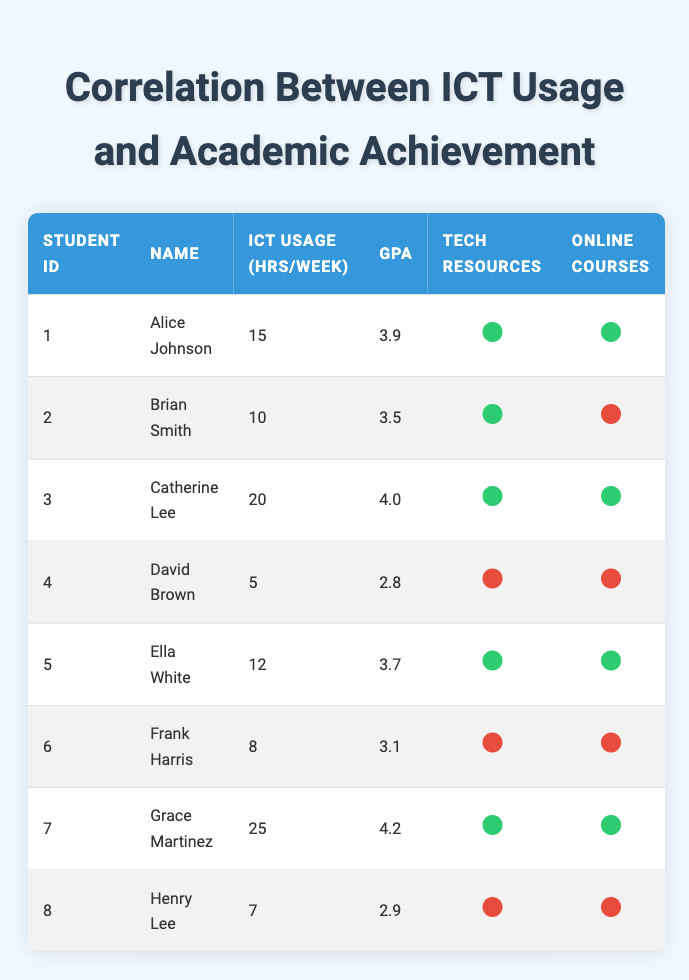What is the GPA of the student who uses ICT for 25 hours per week? Referring to the table, Grace Martinez is the student who uses ICT for 25 hours per week, and her GPA is 4.2.
Answer: 4.2 How many students have access to tech resources? By checking the table, students Alice Johnson, Brian Smith, Catherine Lee, Ella White, Grace Martinez have access to tech resources. This totals to 5 students.
Answer: 5 What is the average GPA of students who participate in online courses? The students who participate in online courses are Alice Johnson, Catherine Lee, Ella White, and Grace Martinez. Their GPAs are 3.9, 4.0, 3.7, and 4.2. The total GPA sum is 15.8, and divided by 4 gives an average of 3.95.
Answer: 3.95 Is there any student who uses ICT for more than 20 hours and has a GPA below 3.5? Referring to the table, Grace Martinez uses ICT for 25 hours and has a GPA of 4.2, and Catherine Lee uses ICT for 20 hours and has a GPA of 4.0. Thus, there is no student fitting this criteria.
Answer: No What is the difference between the highest and lowest GPA among students with access to tech resources? The highest GPA among students with access to tech resources is 4.2 (Grace Martinez) and the lowest is 3.5 (Brian Smith). The difference is 4.2 - 3.5 = 0.7.
Answer: 0.7 How many total ICT usage hours per week is reported by students who don't have access to tech resources? The students without access to tech resources are David Brown, Frank Harris, and Henry Lee. Their ICT usage hours are 5, 8 and 7 respectively. Total ICT usage is 5 + 8 + 7 = 20 hours.
Answer: 20 Which student has the lowest GPA and does not participate in online courses? By checking the table, David Brown has the lowest GPA at 2.8 and does not participate in online courses.
Answer: David Brown How many students have both access to tech resources and participate in online courses? From the table, the students who meet both criteria are Alice Johnson, Catherine Lee, Ella White, and Grace Martinez. Thus, there are 4 such students.
Answer: 4 